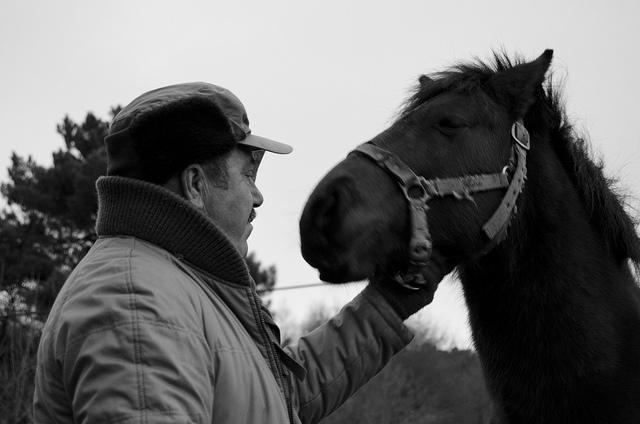How many people can you see?
Give a very brief answer. 1. How many people are on a motorcycle in the image?
Give a very brief answer. 0. 